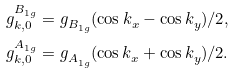Convert formula to latex. <formula><loc_0><loc_0><loc_500><loc_500>g ^ { B ^ { \ } _ { 1 g } } _ { k , 0 } & = g ^ { \ } _ { B ^ { \ } _ { 1 g } } ( \cos k ^ { \ } _ { x } - \cos k ^ { \ } _ { y } ) / 2 , \\ g ^ { A ^ { \ } _ { 1 g } } _ { k , 0 } & = g ^ { \ } _ { A ^ { \ } _ { 1 g } } ( \cos k ^ { \ } _ { x } + \cos k ^ { \ } _ { y } ) / 2 .</formula> 